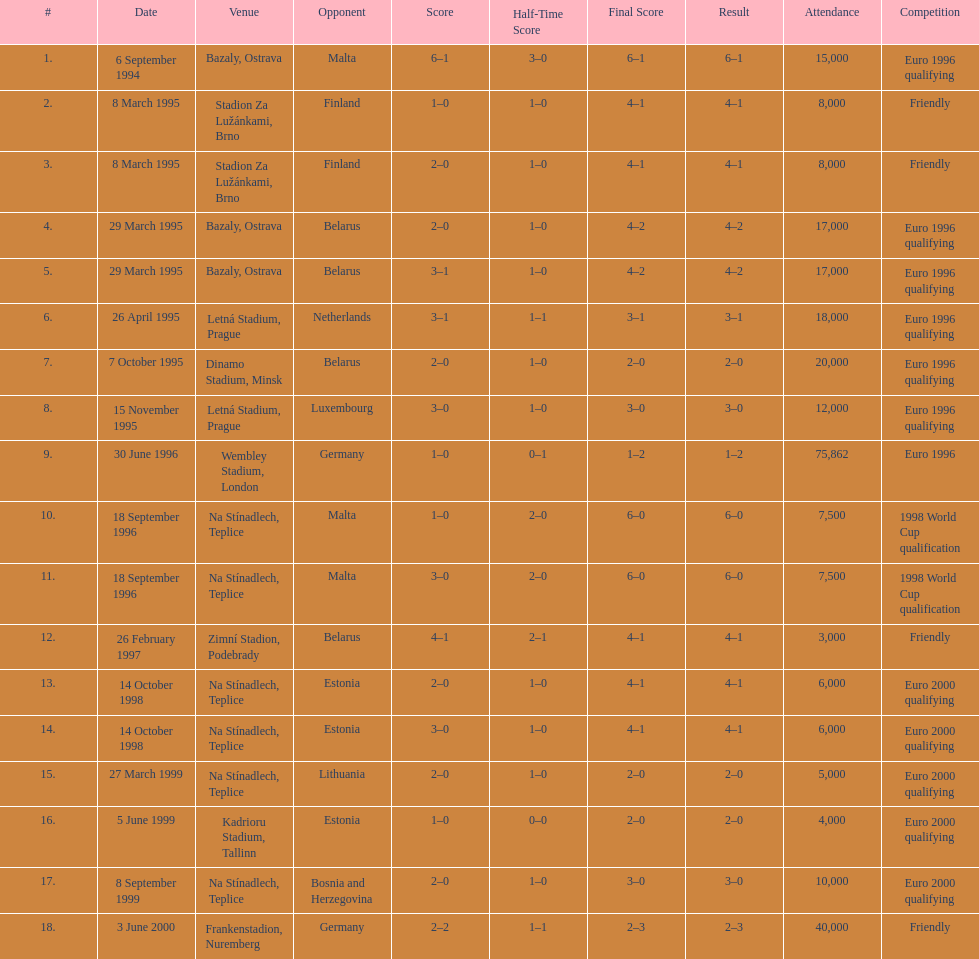What opponent is listed last on the table? Germany. 